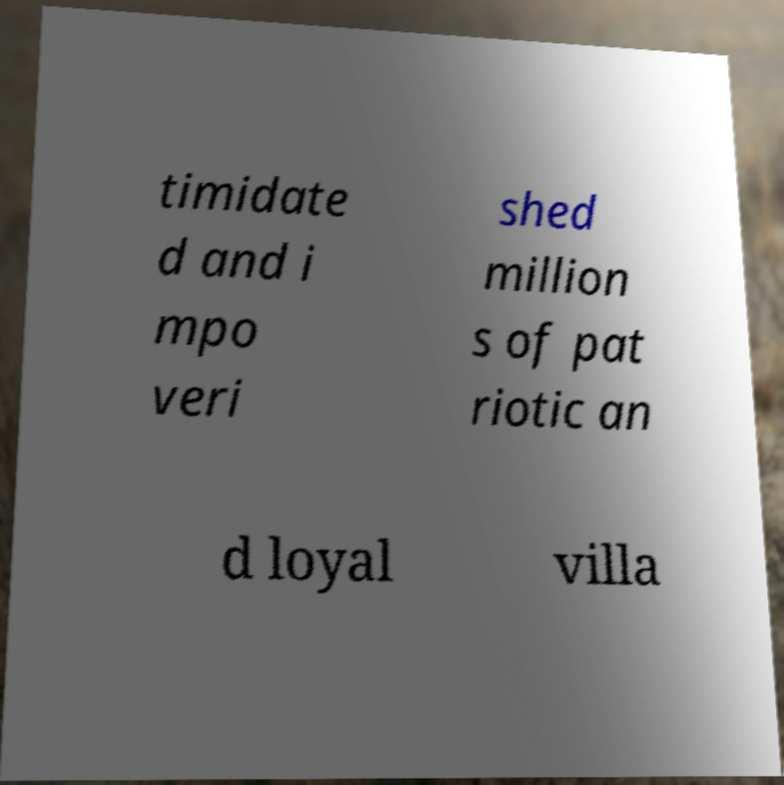Can you read and provide the text displayed in the image?This photo seems to have some interesting text. Can you extract and type it out for me? timidate d and i mpo veri shed million s of pat riotic an d loyal villa 